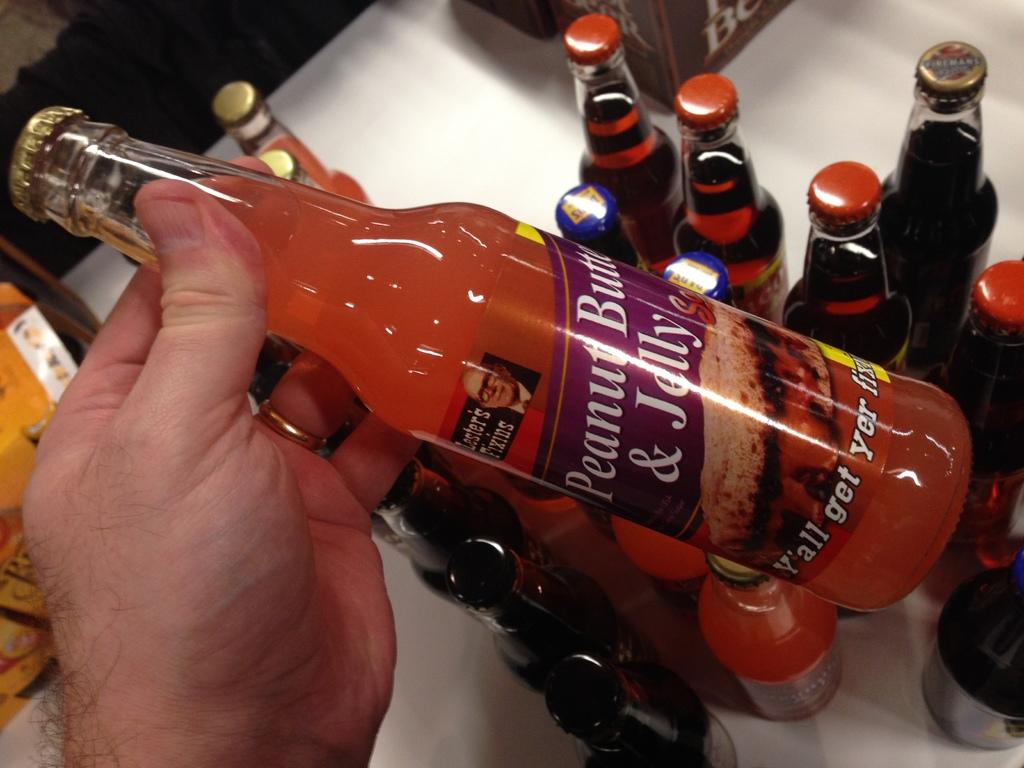<image>
Provide a brief description of the given image. A man holding a soda bottle named Peanut Butter and Jelly. 